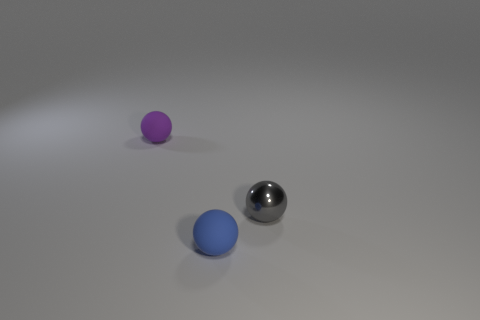Add 2 large purple matte cubes. How many objects exist? 5 Add 1 small gray things. How many small gray things exist? 2 Subtract 0 yellow cylinders. How many objects are left? 3 Subtract all small blue cubes. Subtract all small objects. How many objects are left? 0 Add 1 purple things. How many purple things are left? 2 